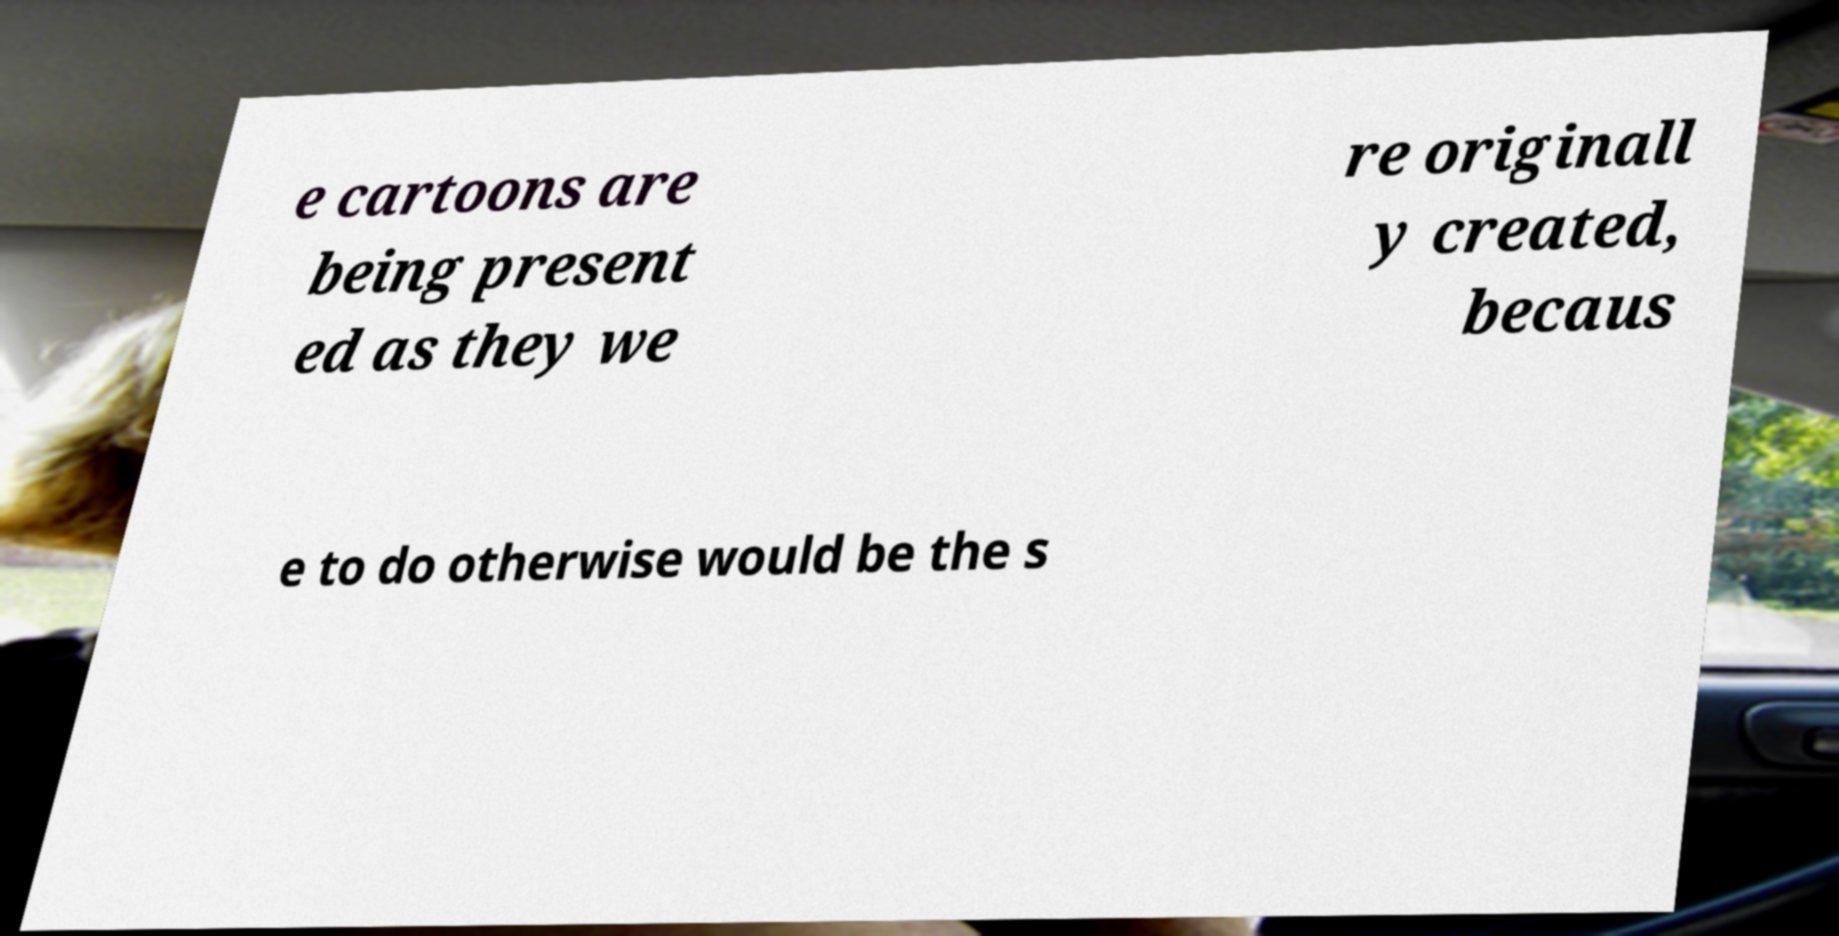Could you assist in decoding the text presented in this image and type it out clearly? e cartoons are being present ed as they we re originall y created, becaus e to do otherwise would be the s 